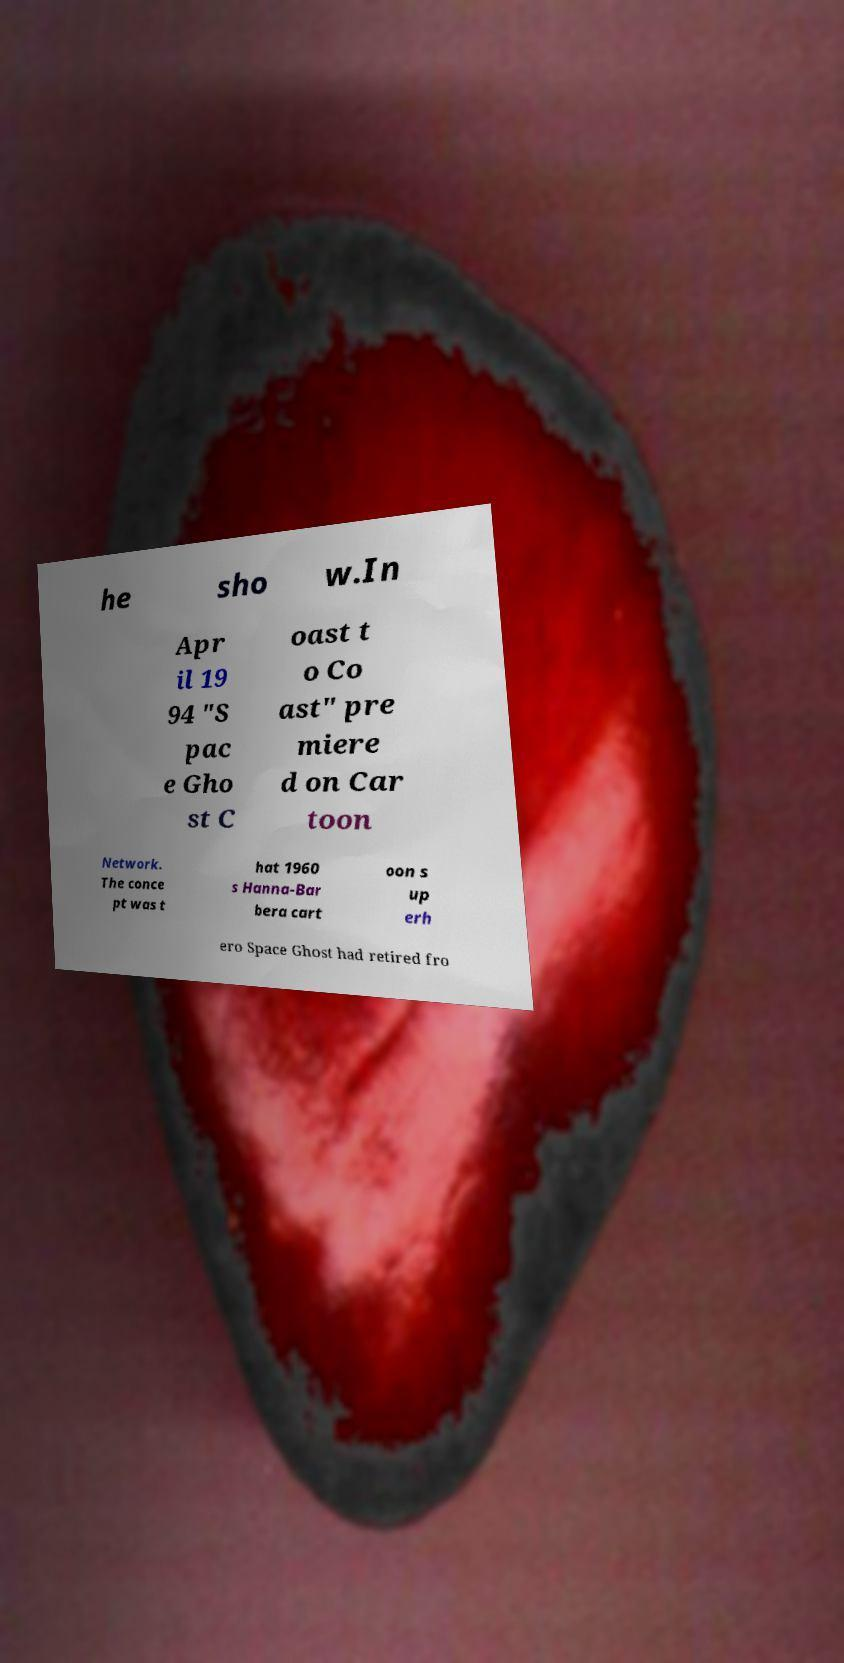Could you extract and type out the text from this image? he sho w.In Apr il 19 94 "S pac e Gho st C oast t o Co ast" pre miere d on Car toon Network. The conce pt was t hat 1960 s Hanna-Bar bera cart oon s up erh ero Space Ghost had retired fro 